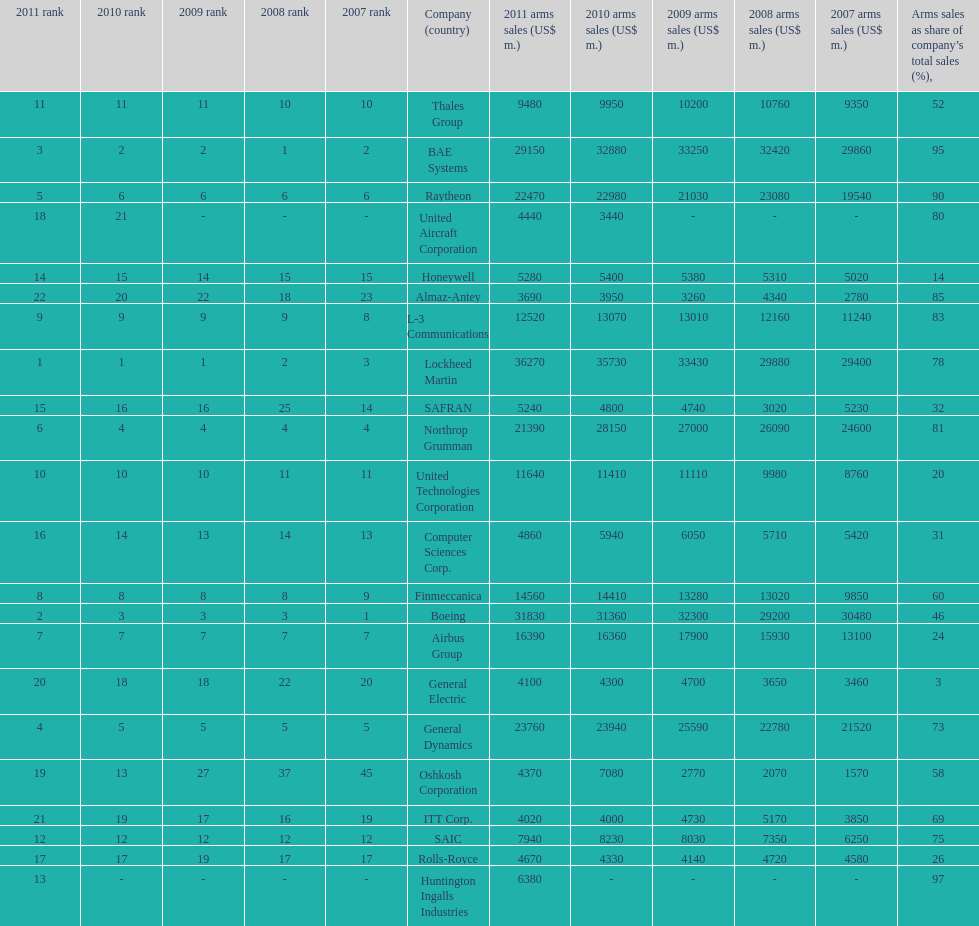How many companies are under the united states? 14. 